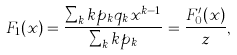<formula> <loc_0><loc_0><loc_500><loc_500>F _ { 1 } ( x ) = \frac { \sum _ { k } k p _ { k } q _ { k } x ^ { k - 1 } } { \sum _ { k } k p _ { k } } = \frac { F _ { 0 } ^ { \prime } ( x ) } { z } ,</formula> 